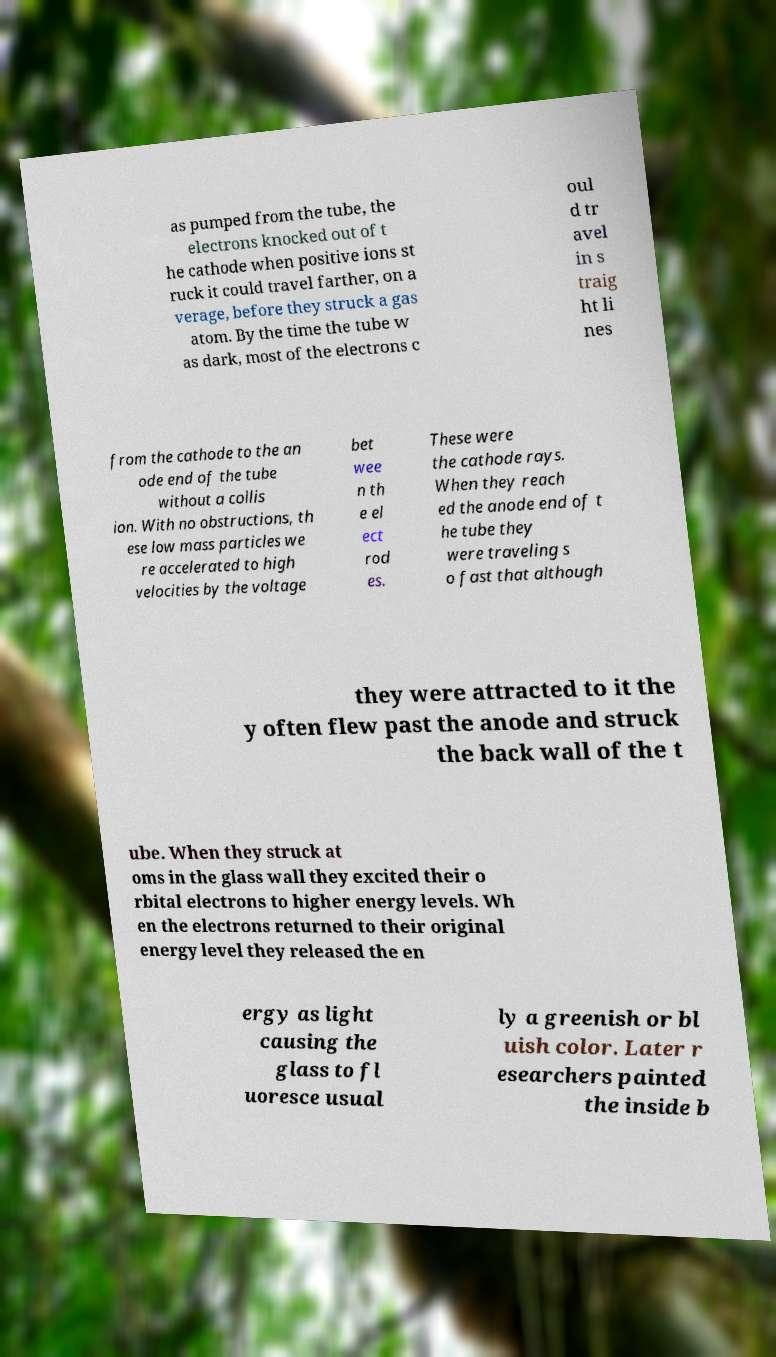Please identify and transcribe the text found in this image. as pumped from the tube, the electrons knocked out of t he cathode when positive ions st ruck it could travel farther, on a verage, before they struck a gas atom. By the time the tube w as dark, most of the electrons c oul d tr avel in s traig ht li nes from the cathode to the an ode end of the tube without a collis ion. With no obstructions, th ese low mass particles we re accelerated to high velocities by the voltage bet wee n th e el ect rod es. These were the cathode rays. When they reach ed the anode end of t he tube they were traveling s o fast that although they were attracted to it the y often flew past the anode and struck the back wall of the t ube. When they struck at oms in the glass wall they excited their o rbital electrons to higher energy levels. Wh en the electrons returned to their original energy level they released the en ergy as light causing the glass to fl uoresce usual ly a greenish or bl uish color. Later r esearchers painted the inside b 